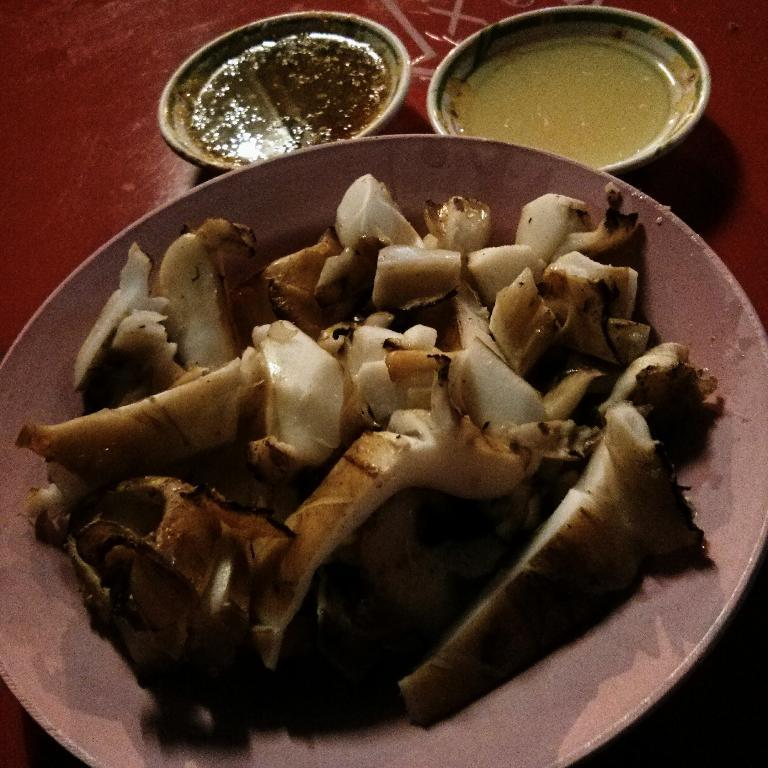What objects are present on the table in the image? There are plates in the image. What is on top of the plates? There are food items on the plates. Where are the plates located? The plates are on a table. What type of brass instrument can be seen on the table in the image? There is no brass instrument present in the image; it features plates with food items. 